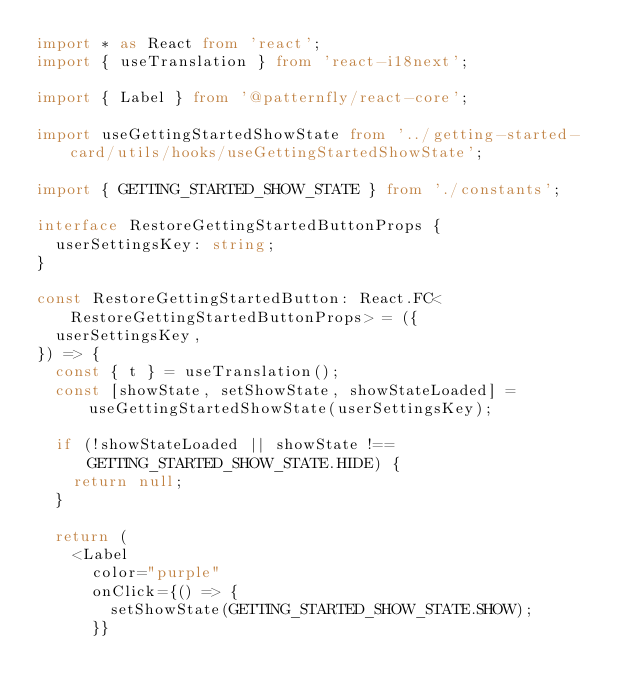<code> <loc_0><loc_0><loc_500><loc_500><_TypeScript_>import * as React from 'react';
import { useTranslation } from 'react-i18next';

import { Label } from '@patternfly/react-core';

import useGettingStartedShowState from '../getting-started-card/utils/hooks/useGettingStartedShowState';

import { GETTING_STARTED_SHOW_STATE } from './constants';

interface RestoreGettingStartedButtonProps {
  userSettingsKey: string;
}

const RestoreGettingStartedButton: React.FC<RestoreGettingStartedButtonProps> = ({
  userSettingsKey,
}) => {
  const { t } = useTranslation();
  const [showState, setShowState, showStateLoaded] = useGettingStartedShowState(userSettingsKey);

  if (!showStateLoaded || showState !== GETTING_STARTED_SHOW_STATE.HIDE) {
    return null;
  }

  return (
    <Label
      color="purple"
      onClick={() => {
        setShowState(GETTING_STARTED_SHOW_STATE.SHOW);
      }}</code> 